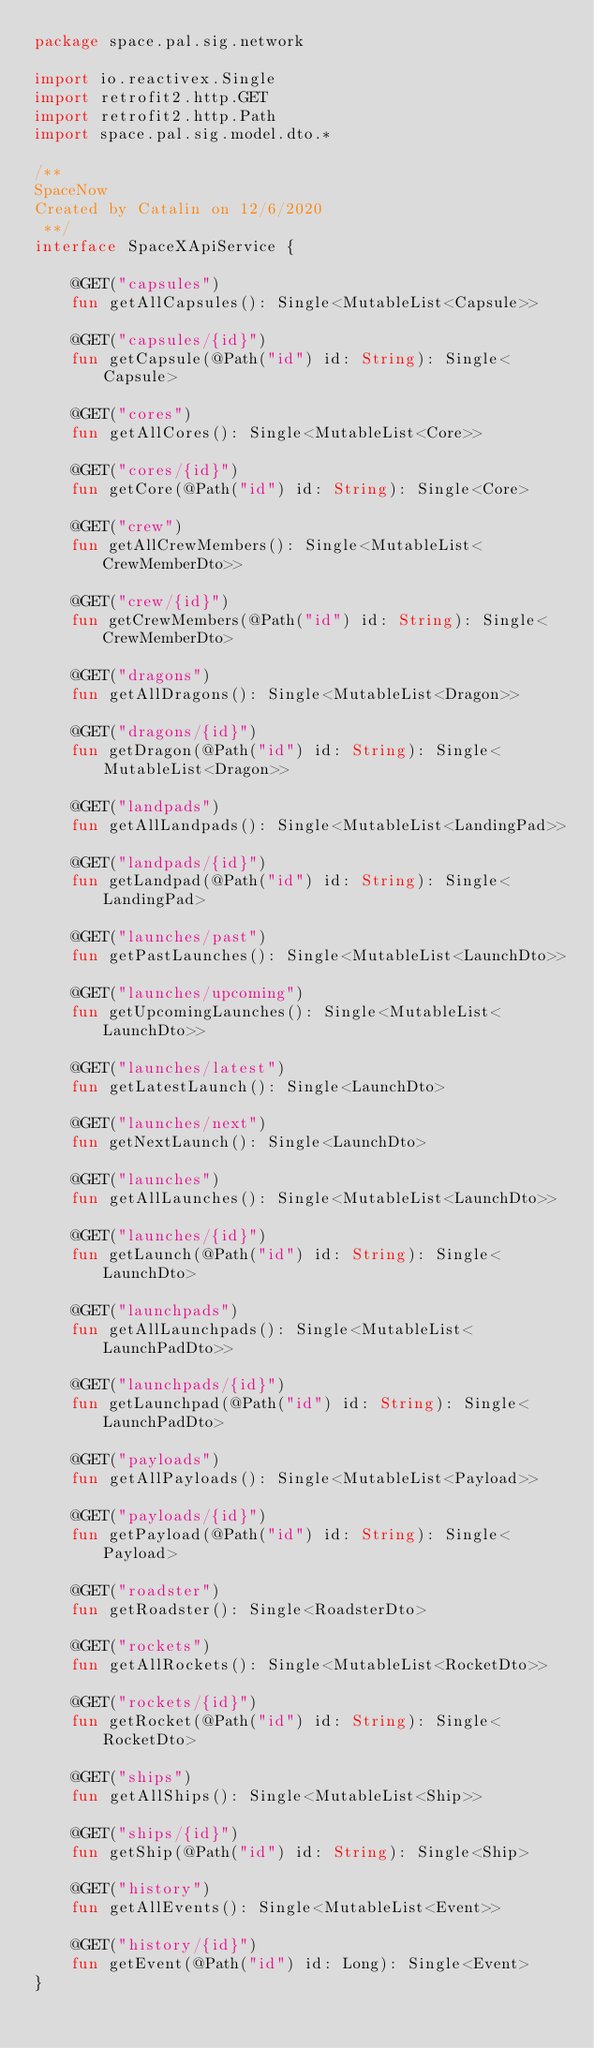Convert code to text. <code><loc_0><loc_0><loc_500><loc_500><_Kotlin_>package space.pal.sig.network

import io.reactivex.Single
import retrofit2.http.GET
import retrofit2.http.Path
import space.pal.sig.model.dto.*

/**
SpaceNow
Created by Catalin on 12/6/2020
 **/
interface SpaceXApiService {

    @GET("capsules")
    fun getAllCapsules(): Single<MutableList<Capsule>>

    @GET("capsules/{id}")
    fun getCapsule(@Path("id") id: String): Single<Capsule>

    @GET("cores")
    fun getAllCores(): Single<MutableList<Core>>

    @GET("cores/{id}")
    fun getCore(@Path("id") id: String): Single<Core>

    @GET("crew")
    fun getAllCrewMembers(): Single<MutableList<CrewMemberDto>>

    @GET("crew/{id}")
    fun getCrewMembers(@Path("id") id: String): Single<CrewMemberDto>

    @GET("dragons")
    fun getAllDragons(): Single<MutableList<Dragon>>

    @GET("dragons/{id}")
    fun getDragon(@Path("id") id: String): Single<MutableList<Dragon>>

    @GET("landpads")
    fun getAllLandpads(): Single<MutableList<LandingPad>>

    @GET("landpads/{id}")
    fun getLandpad(@Path("id") id: String): Single<LandingPad>

    @GET("launches/past")
    fun getPastLaunches(): Single<MutableList<LaunchDto>>

    @GET("launches/upcoming")
    fun getUpcomingLaunches(): Single<MutableList<LaunchDto>>

    @GET("launches/latest")
    fun getLatestLaunch(): Single<LaunchDto>

    @GET("launches/next")
    fun getNextLaunch(): Single<LaunchDto>

    @GET("launches")
    fun getAllLaunches(): Single<MutableList<LaunchDto>>

    @GET("launches/{id}")
    fun getLaunch(@Path("id") id: String): Single<LaunchDto>

    @GET("launchpads")
    fun getAllLaunchpads(): Single<MutableList<LaunchPadDto>>

    @GET("launchpads/{id}")
    fun getLaunchpad(@Path("id") id: String): Single<LaunchPadDto>

    @GET("payloads")
    fun getAllPayloads(): Single<MutableList<Payload>>

    @GET("payloads/{id}")
    fun getPayload(@Path("id") id: String): Single<Payload>

    @GET("roadster")
    fun getRoadster(): Single<RoadsterDto>

    @GET("rockets")
    fun getAllRockets(): Single<MutableList<RocketDto>>

    @GET("rockets/{id}")
    fun getRocket(@Path("id") id: String): Single<RocketDto>

    @GET("ships")
    fun getAllShips(): Single<MutableList<Ship>>

    @GET("ships/{id}")
    fun getShip(@Path("id") id: String): Single<Ship>

    @GET("history")
    fun getAllEvents(): Single<MutableList<Event>>

    @GET("history/{id}")
    fun getEvent(@Path("id") id: Long): Single<Event>
}</code> 